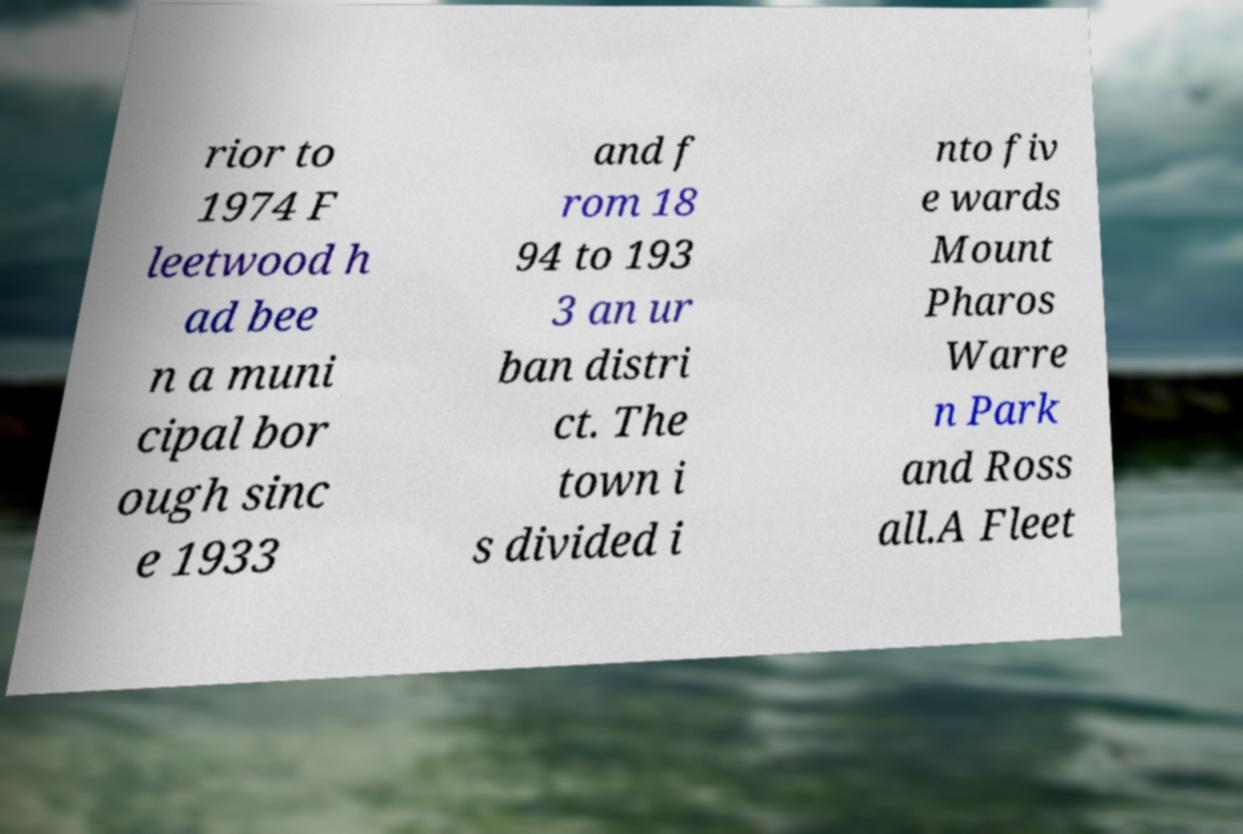Could you assist in decoding the text presented in this image and type it out clearly? rior to 1974 F leetwood h ad bee n a muni cipal bor ough sinc e 1933 and f rom 18 94 to 193 3 an ur ban distri ct. The town i s divided i nto fiv e wards Mount Pharos Warre n Park and Ross all.A Fleet 